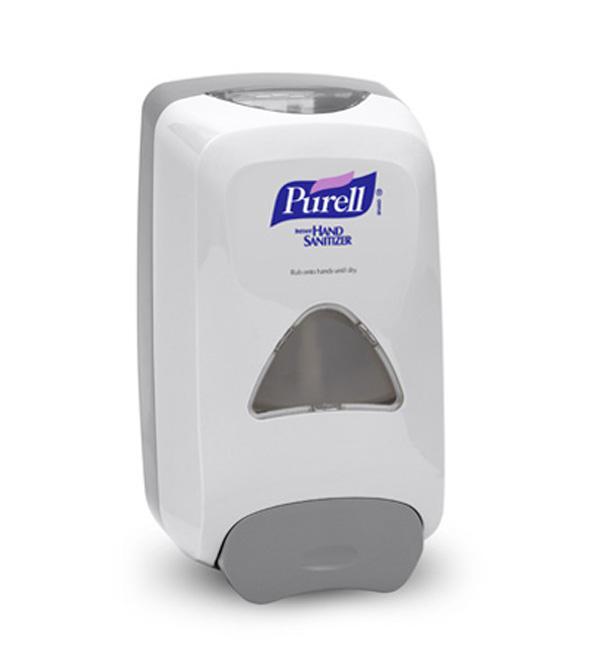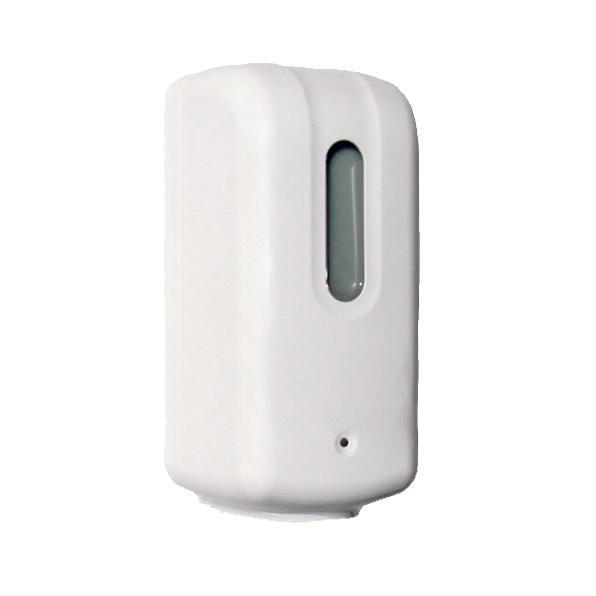The first image is the image on the left, the second image is the image on the right. Assess this claim about the two images: "There is a human hand in the image on the left.". Correct or not? Answer yes or no. No. 